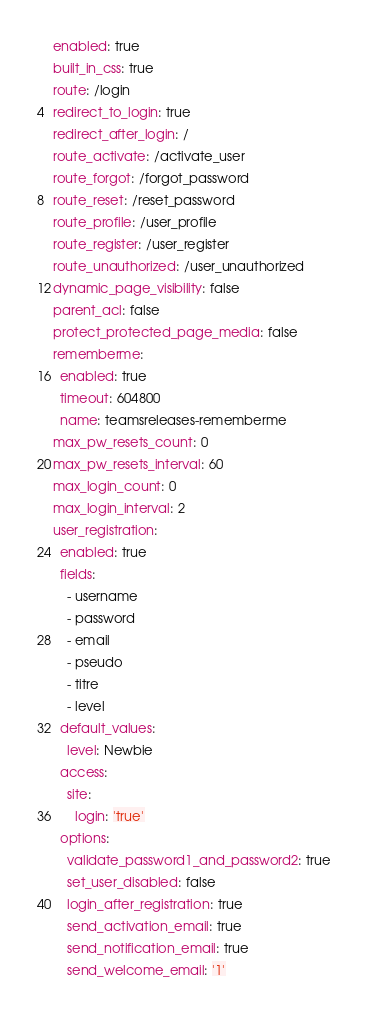Convert code to text. <code><loc_0><loc_0><loc_500><loc_500><_YAML_>enabled: true
built_in_css: true
route: /login
redirect_to_login: true
redirect_after_login: /
route_activate: /activate_user
route_forgot: /forgot_password
route_reset: /reset_password
route_profile: /user_profile
route_register: /user_register
route_unauthorized: /user_unauthorized
dynamic_page_visibility: false
parent_acl: false
protect_protected_page_media: false
rememberme:
  enabled: true
  timeout: 604800
  name: teamsreleases-rememberme
max_pw_resets_count: 0
max_pw_resets_interval: 60
max_login_count: 0
max_login_interval: 2
user_registration:
  enabled: true
  fields:
    - username
    - password
    - email
    - pseudo
    - titre
    - level
  default_values:
    level: Newbie
  access:
    site:
      login: 'true'
  options:
    validate_password1_and_password2: true
    set_user_disabled: false
    login_after_registration: true
    send_activation_email: true
    send_notification_email: true
    send_welcome_email: '1'
</code> 